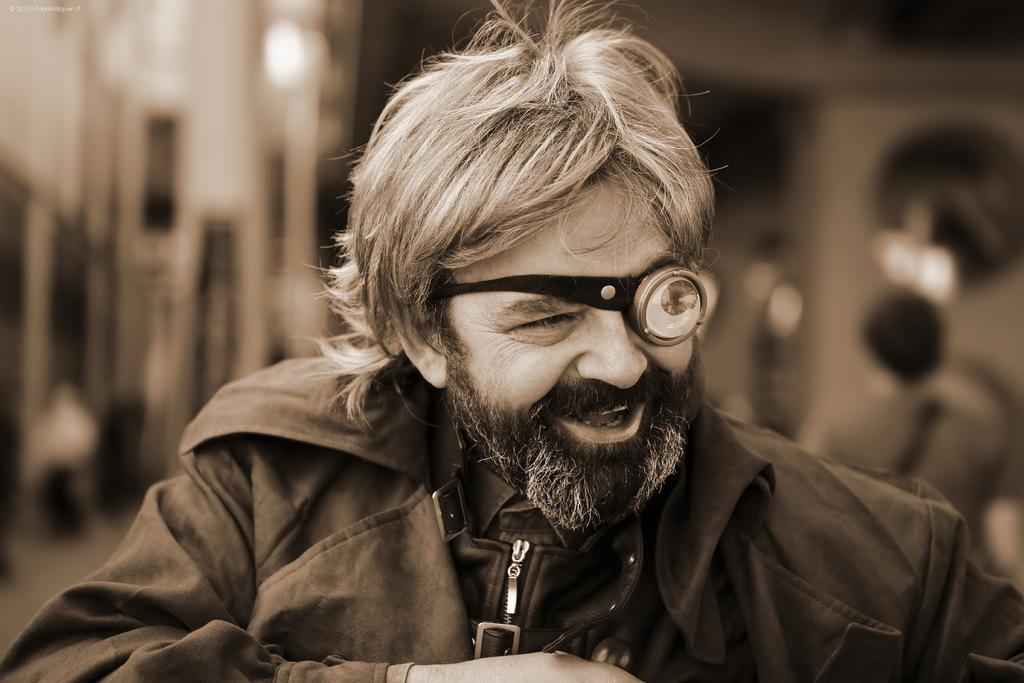What is present in the image? There is a person in the image. How is the person's expression? The person is smiling. Can you describe the background of the image? The background of the image is blurred. What type of pancake is the person holding in the image? There is no pancake present in the image. How many kittens are visible on the tray in the image? There is no tray or kittens present in the image. 